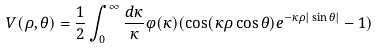<formula> <loc_0><loc_0><loc_500><loc_500>V ( \rho , \theta ) = \frac { 1 } { 2 } \int _ { 0 } ^ { \infty } \frac { d \kappa } { \kappa } \varphi ( \kappa ) ( \cos ( \kappa \rho \cos \theta ) e ^ { - \kappa \rho | \sin \theta | } - 1 )</formula> 